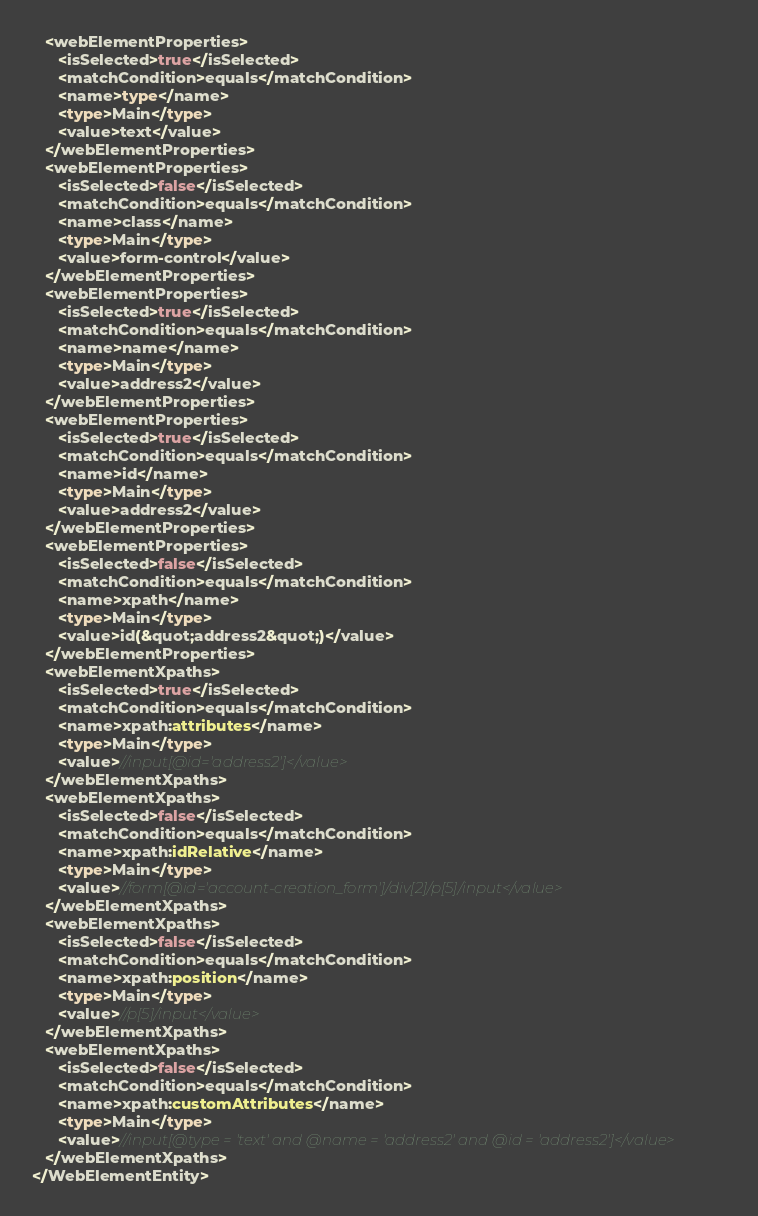<code> <loc_0><loc_0><loc_500><loc_500><_Rust_>   <webElementProperties>
      <isSelected>true</isSelected>
      <matchCondition>equals</matchCondition>
      <name>type</name>
      <type>Main</type>
      <value>text</value>
   </webElementProperties>
   <webElementProperties>
      <isSelected>false</isSelected>
      <matchCondition>equals</matchCondition>
      <name>class</name>
      <type>Main</type>
      <value>form-control</value>
   </webElementProperties>
   <webElementProperties>
      <isSelected>true</isSelected>
      <matchCondition>equals</matchCondition>
      <name>name</name>
      <type>Main</type>
      <value>address2</value>
   </webElementProperties>
   <webElementProperties>
      <isSelected>true</isSelected>
      <matchCondition>equals</matchCondition>
      <name>id</name>
      <type>Main</type>
      <value>address2</value>
   </webElementProperties>
   <webElementProperties>
      <isSelected>false</isSelected>
      <matchCondition>equals</matchCondition>
      <name>xpath</name>
      <type>Main</type>
      <value>id(&quot;address2&quot;)</value>
   </webElementProperties>
   <webElementXpaths>
      <isSelected>true</isSelected>
      <matchCondition>equals</matchCondition>
      <name>xpath:attributes</name>
      <type>Main</type>
      <value>//input[@id='address2']</value>
   </webElementXpaths>
   <webElementXpaths>
      <isSelected>false</isSelected>
      <matchCondition>equals</matchCondition>
      <name>xpath:idRelative</name>
      <type>Main</type>
      <value>//form[@id='account-creation_form']/div[2]/p[5]/input</value>
   </webElementXpaths>
   <webElementXpaths>
      <isSelected>false</isSelected>
      <matchCondition>equals</matchCondition>
      <name>xpath:position</name>
      <type>Main</type>
      <value>//p[5]/input</value>
   </webElementXpaths>
   <webElementXpaths>
      <isSelected>false</isSelected>
      <matchCondition>equals</matchCondition>
      <name>xpath:customAttributes</name>
      <type>Main</type>
      <value>//input[@type = 'text' and @name = 'address2' and @id = 'address2']</value>
   </webElementXpaths>
</WebElementEntity>
</code> 